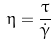<formula> <loc_0><loc_0><loc_500><loc_500>\eta = \frac { \tau } { \dot { \gamma } }</formula> 